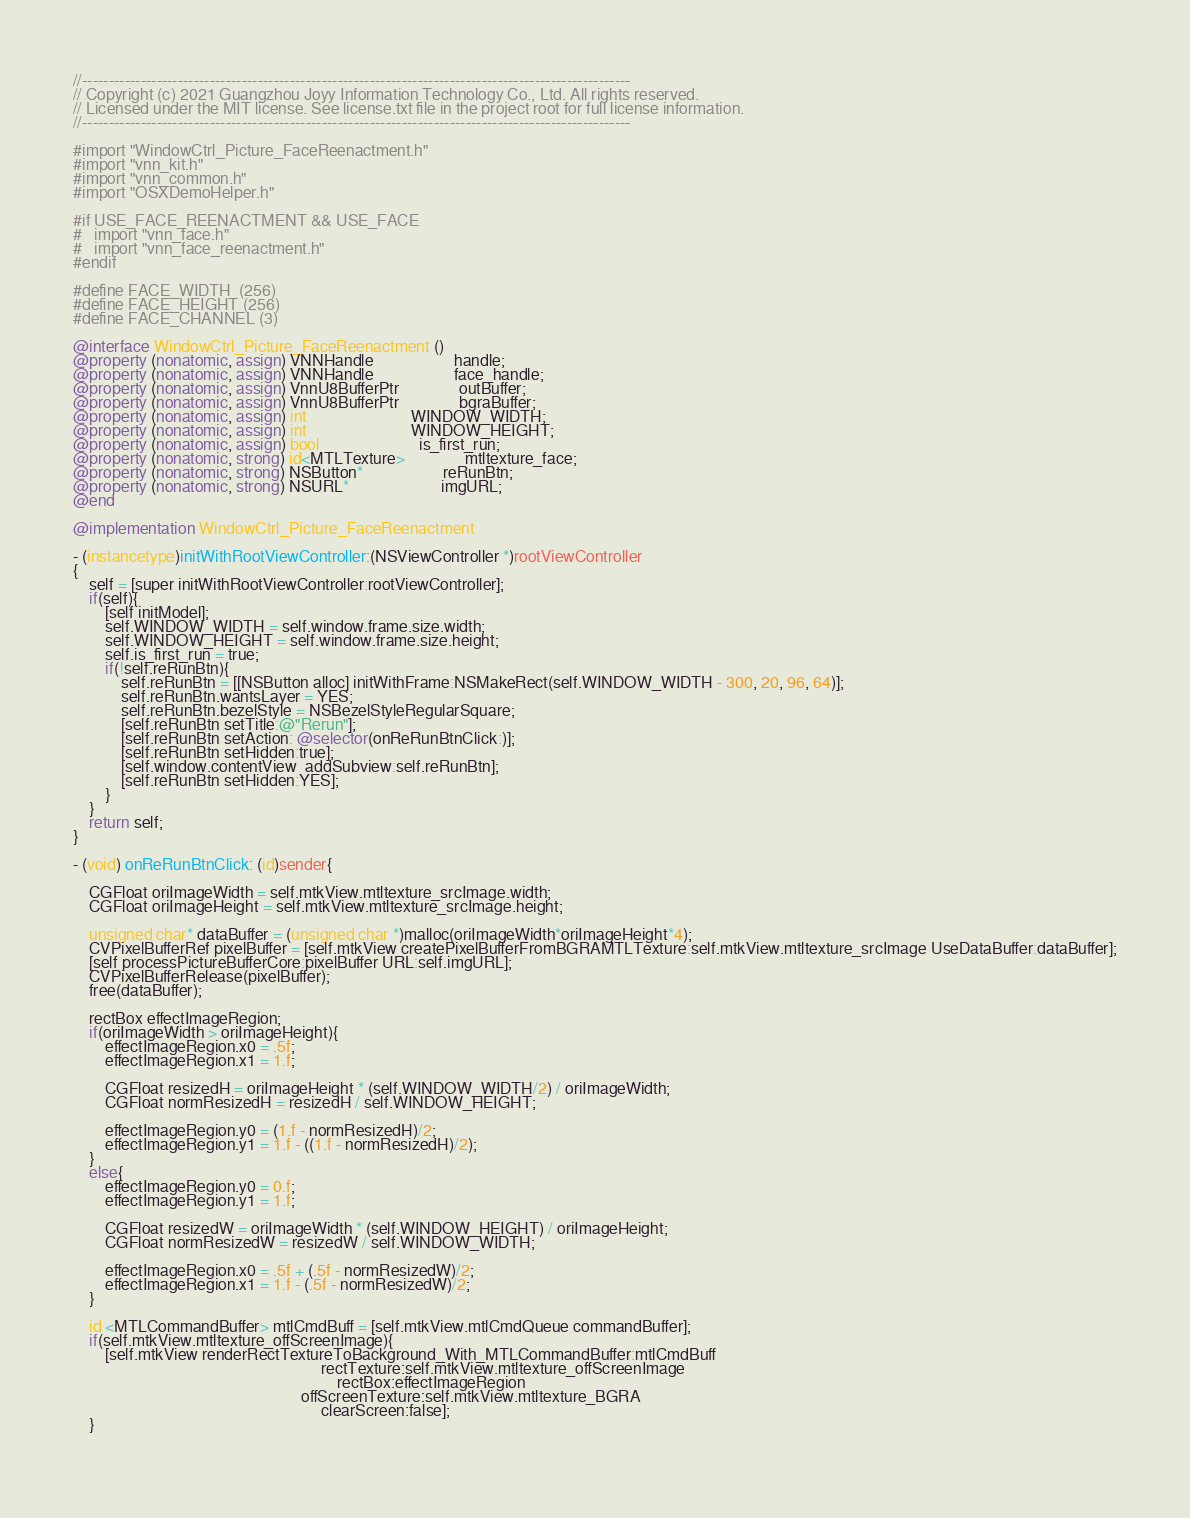Convert code to text. <code><loc_0><loc_0><loc_500><loc_500><_ObjectiveC_>//-------------------------------------------------------------------------------------------------------
// Copyright (c) 2021 Guangzhou Joyy Information Technology Co., Ltd. All rights reserved.
// Licensed under the MIT license. See license.txt file in the project root for full license information.
//-------------------------------------------------------------------------------------------------------

#import "WindowCtrl_Picture_FaceReenactment.h"
#import "vnn_kit.h"
#import "vnn_common.h"
#import "OSXDemoHelper.h"

#if USE_FACE_REENACTMENT && USE_FACE
#   import "vnn_face.h"
#   import "vnn_face_reenactment.h"
#endif

#define FACE_WIDTH  (256)
#define FACE_HEIGHT (256)
#define FACE_CHANNEL (3)

@interface WindowCtrl_Picture_FaceReenactment ()
@property (nonatomic, assign) VNNHandle                    handle;
@property (nonatomic, assign) VNNHandle                    face_handle;
@property (nonatomic, assign) VnnU8BufferPtr               outBuffer;
@property (nonatomic, assign) VnnU8BufferPtr               bgraBuffer;
@property (nonatomic, assign) int                          WINDOW_WIDTH;
@property (nonatomic, assign) int                          WINDOW_HEIGHT;
@property (nonatomic, assign) bool                         is_first_run;
@property (nonatomic, strong) id<MTLTexture>               mtltexture_face;
@property (nonatomic, strong) NSButton*                    reRunBtn;
@property (nonatomic, strong) NSURL*                       imgURL;
@end

@implementation WindowCtrl_Picture_FaceReenactment

- (instancetype)initWithRootViewController:(NSViewController *)rootViewController
{
    self = [super initWithRootViewController:rootViewController];
    if(self){
        [self initModel];
        self.WINDOW_WIDTH = self.window.frame.size.width;
        self.WINDOW_HEIGHT = self.window.frame.size.height;
        self.is_first_run = true;
        if(!self.reRunBtn){
            self.reRunBtn = [[NSButton alloc] initWithFrame:NSMakeRect(self.WINDOW_WIDTH - 300, 20, 96, 64)];
            self.reRunBtn.wantsLayer = YES;
            self.reRunBtn.bezelStyle = NSBezelStyleRegularSquare;
            [self.reRunBtn setTitle:@"Rerun"];
            [self.reRunBtn setAction: @selector(onReRunBtnClick:)];
            [self.reRunBtn setHidden:true];
            [self.window.contentView  addSubview:self.reRunBtn];
            [self.reRunBtn setHidden:YES];
        }
    }
    return self;
}

- (void) onReRunBtnClick: (id)sender{
    
    CGFloat oriImageWidth = self.mtkView.mtltexture_srcImage.width;
    CGFloat oriImageHeight = self.mtkView.mtltexture_srcImage.height;
    
    unsigned char* dataBuffer = (unsigned char *)malloc(oriImageWidth*oriImageHeight*4);
    CVPixelBufferRef pixelBuffer = [self.mtkView createPixelBufferFromBGRAMTLTexture:self.mtkView.mtltexture_srcImage UseDataBuffer:dataBuffer];
    [self processPictureBufferCore:pixelBuffer URL:self.imgURL];
    CVPixelBufferRelease(pixelBuffer);
    free(dataBuffer);
    
    rectBox effectImageRegion;
    if(oriImageWidth > oriImageHeight){
        effectImageRegion.x0 = .5f;
        effectImageRegion.x1 = 1.f;
        
        CGFloat resizedH = oriImageHeight * (self.WINDOW_WIDTH/2) / oriImageWidth;
        CGFloat normResizedH = resizedH / self.WINDOW_HEIGHT;
        
        effectImageRegion.y0 = (1.f - normResizedH)/2;
        effectImageRegion.y1 = 1.f - ((1.f - normResizedH)/2);
    }
    else{
        effectImageRegion.y0 = 0.f;
        effectImageRegion.y1 = 1.f;
        
        CGFloat resizedW = oriImageWidth * (self.WINDOW_HEIGHT) / oriImageHeight;
        CGFloat normResizedW = resizedW / self.WINDOW_WIDTH;
        
        effectImageRegion.x0 = .5f + (.5f - normResizedW)/2;
        effectImageRegion.x1 = 1.f - (.5f - normResizedW)/2;
    }
    
    id <MTLCommandBuffer> mtlCmdBuff = [self.mtkView.mtlCmdQueue commandBuffer];
    if(self.mtkView.mtltexture_offScreenImage){
        [self.mtkView renderRectTextureToBackground_With_MTLCommandBuffer:mtlCmdBuff
                                                              rectTexture:self.mtkView.mtltexture_offScreenImage
                                                                  rectBox:effectImageRegion
                                                         offScreenTexture:self.mtkView.mtltexture_BGRA
                                                              clearScreen:false];
    }
    </code> 